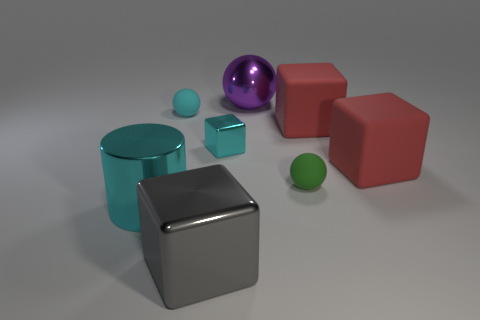How many cubes are behind the tiny shiny thing and in front of the green rubber object?
Offer a terse response. 0. How many other things are there of the same size as the cyan matte sphere?
Your answer should be compact. 2. Does the small thing that is to the right of the large sphere have the same shape as the cyan metallic thing in front of the small green object?
Your answer should be very brief. No. There is a big cyan shiny cylinder; are there any large gray cubes in front of it?
Provide a short and direct response. Yes. The small object that is the same shape as the big gray object is what color?
Offer a terse response. Cyan. Is there anything else that is the same shape as the big cyan object?
Your answer should be compact. No. There is a small sphere that is right of the cyan rubber sphere; what is its material?
Give a very brief answer. Rubber. There is another metallic thing that is the same shape as the gray object; what is its size?
Offer a terse response. Small. What number of cyan spheres have the same material as the large cyan cylinder?
Make the answer very short. 0. How many blocks are the same color as the metal cylinder?
Keep it short and to the point. 1. 